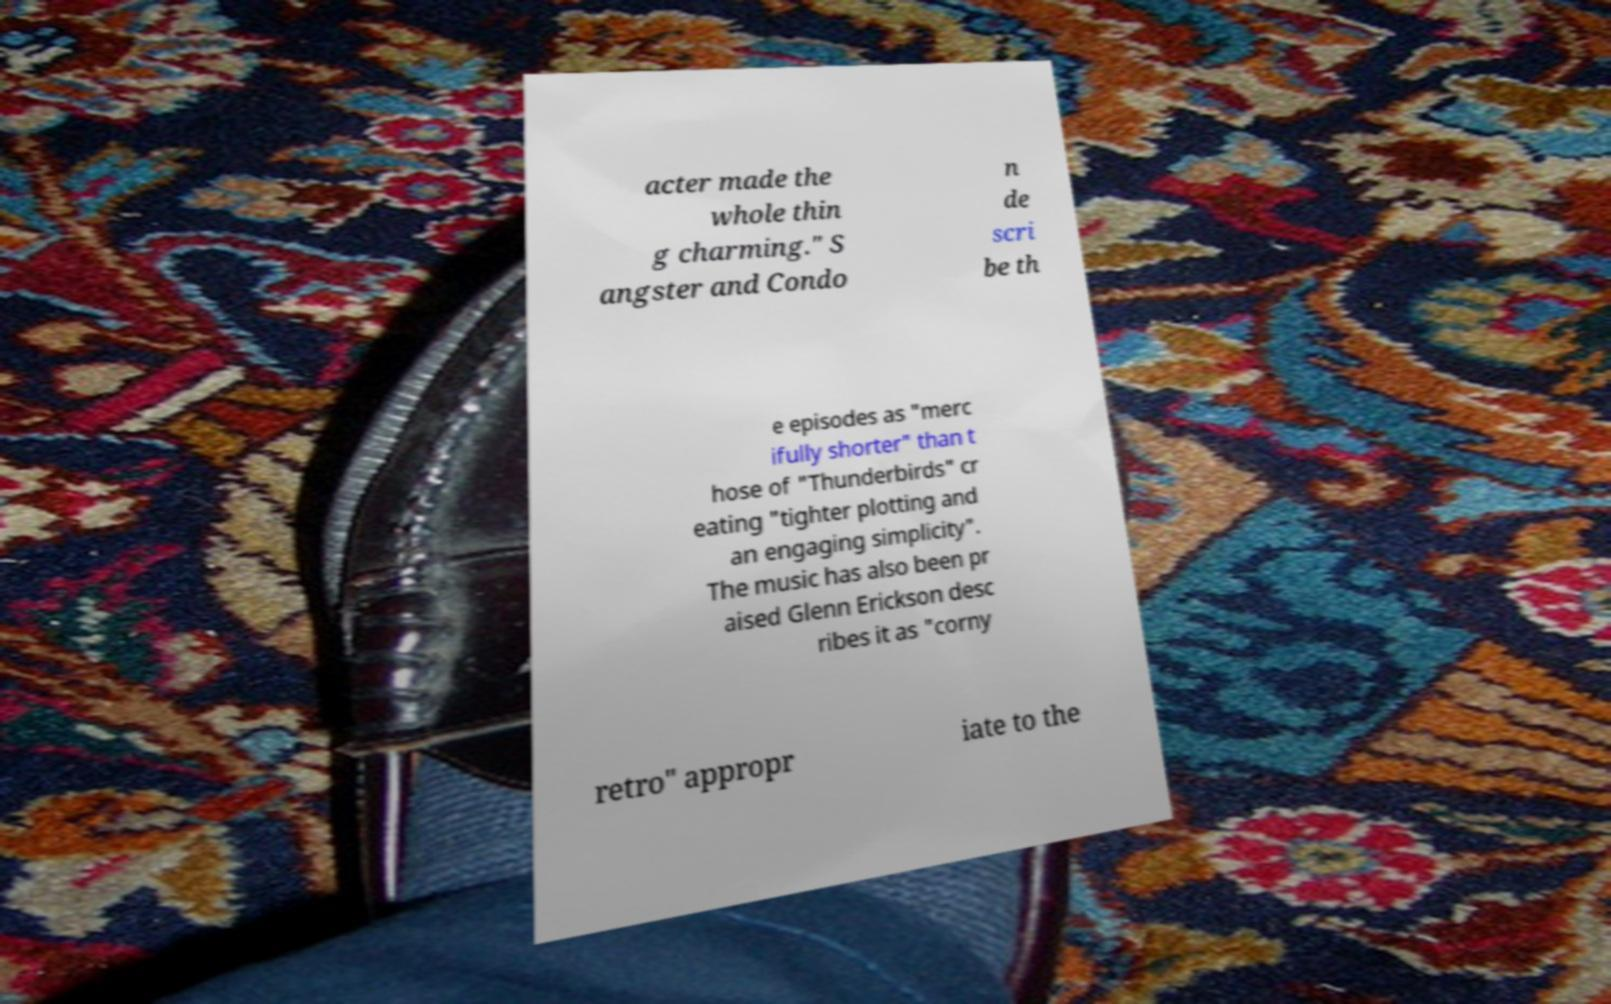There's text embedded in this image that I need extracted. Can you transcribe it verbatim? acter made the whole thin g charming." S angster and Condo n de scri be th e episodes as "merc ifully shorter" than t hose of "Thunderbirds" cr eating "tighter plotting and an engaging simplicity". The music has also been pr aised Glenn Erickson desc ribes it as "corny retro" appropr iate to the 